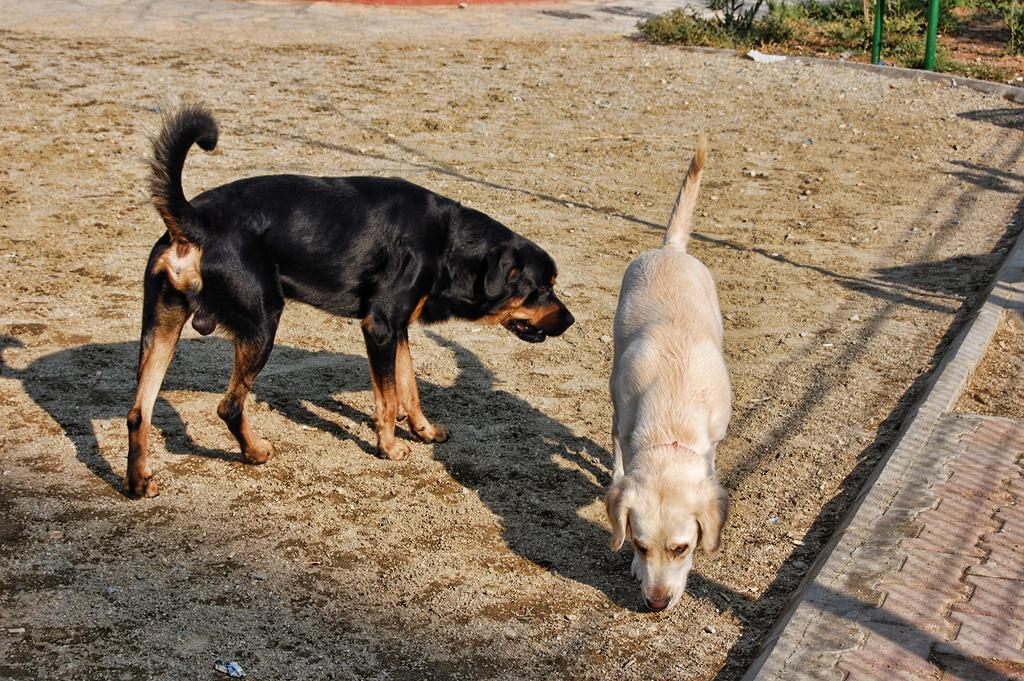What type of animals can be seen in the image? There are dogs in the image. What can be seen in the background of the image? There are plants and metal rods in the background of the image. What type of jam is being served to the mother in the image? There is no mother or jam present in the image; it features dogs and background elements. 